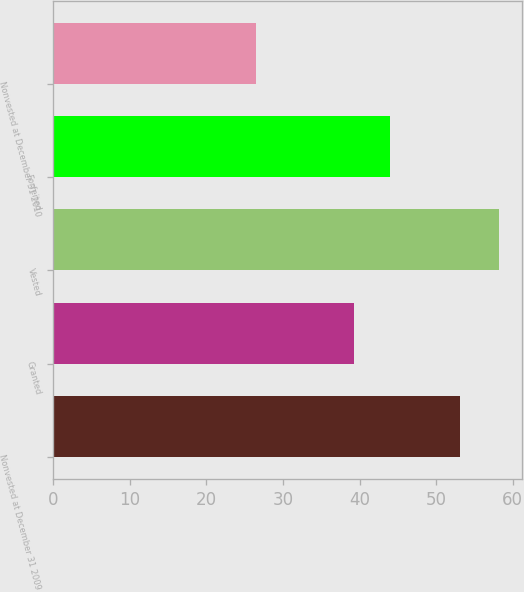<chart> <loc_0><loc_0><loc_500><loc_500><bar_chart><fcel>Nonvested at December 31 2009<fcel>Granted<fcel>Vested<fcel>Forfeited<fcel>Nonvested at December 31 2010<nl><fcel>53.06<fcel>39.33<fcel>58.27<fcel>43.95<fcel>26.44<nl></chart> 